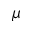Convert formula to latex. <formula><loc_0><loc_0><loc_500><loc_500>\mu</formula> 